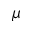Convert formula to latex. <formula><loc_0><loc_0><loc_500><loc_500>\mu</formula> 